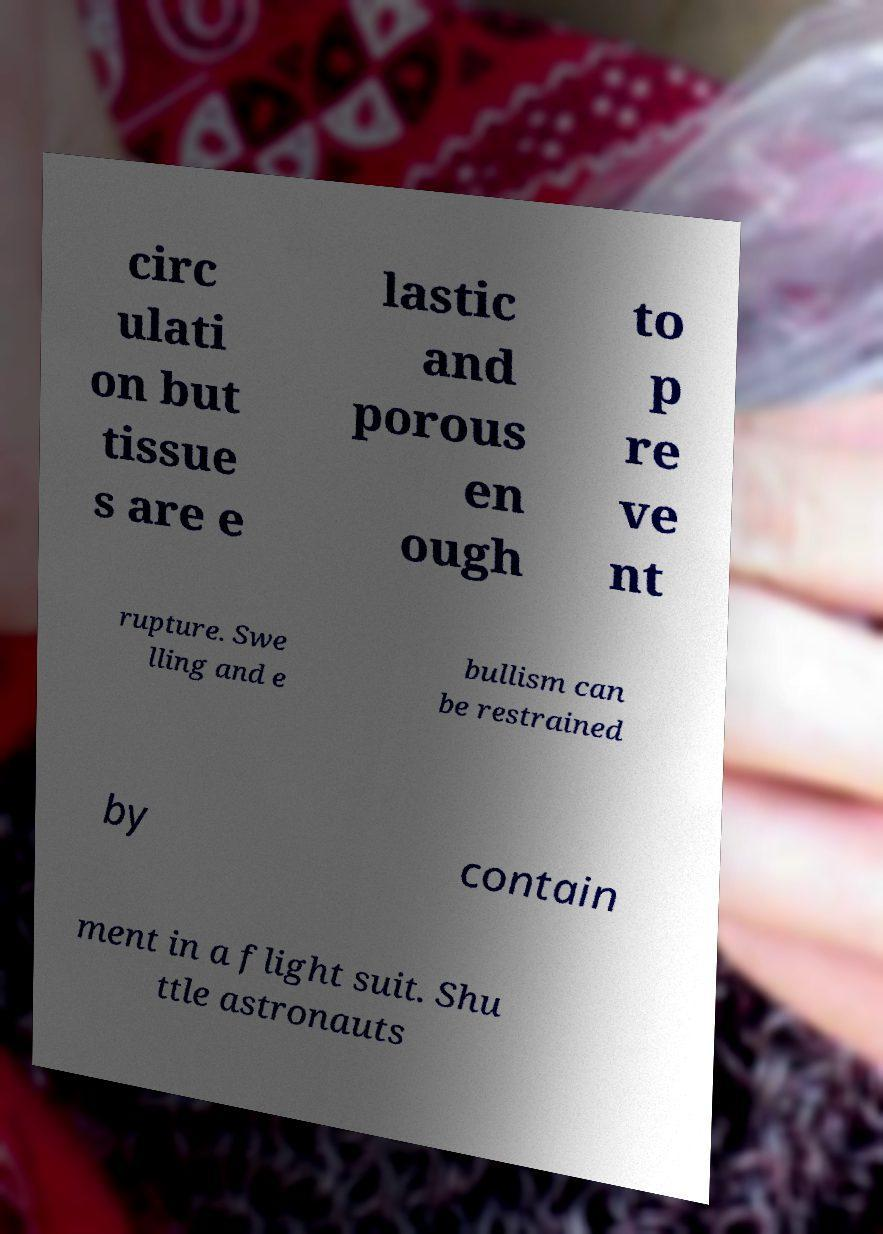There's text embedded in this image that I need extracted. Can you transcribe it verbatim? circ ulati on but tissue s are e lastic and porous en ough to p re ve nt rupture. Swe lling and e bullism can be restrained by contain ment in a flight suit. Shu ttle astronauts 